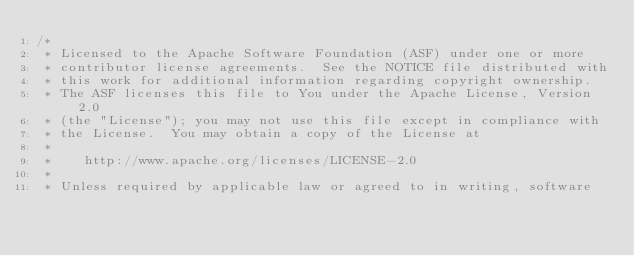Convert code to text. <code><loc_0><loc_0><loc_500><loc_500><_Scala_>/*
 * Licensed to the Apache Software Foundation (ASF) under one or more
 * contributor license agreements.  See the NOTICE file distributed with
 * this work for additional information regarding copyright ownership.
 * The ASF licenses this file to You under the Apache License, Version 2.0
 * (the "License"); you may not use this file except in compliance with
 * the License.  You may obtain a copy of the License at
 *
 *    http://www.apache.org/licenses/LICENSE-2.0
 *
 * Unless required by applicable law or agreed to in writing, software</code> 